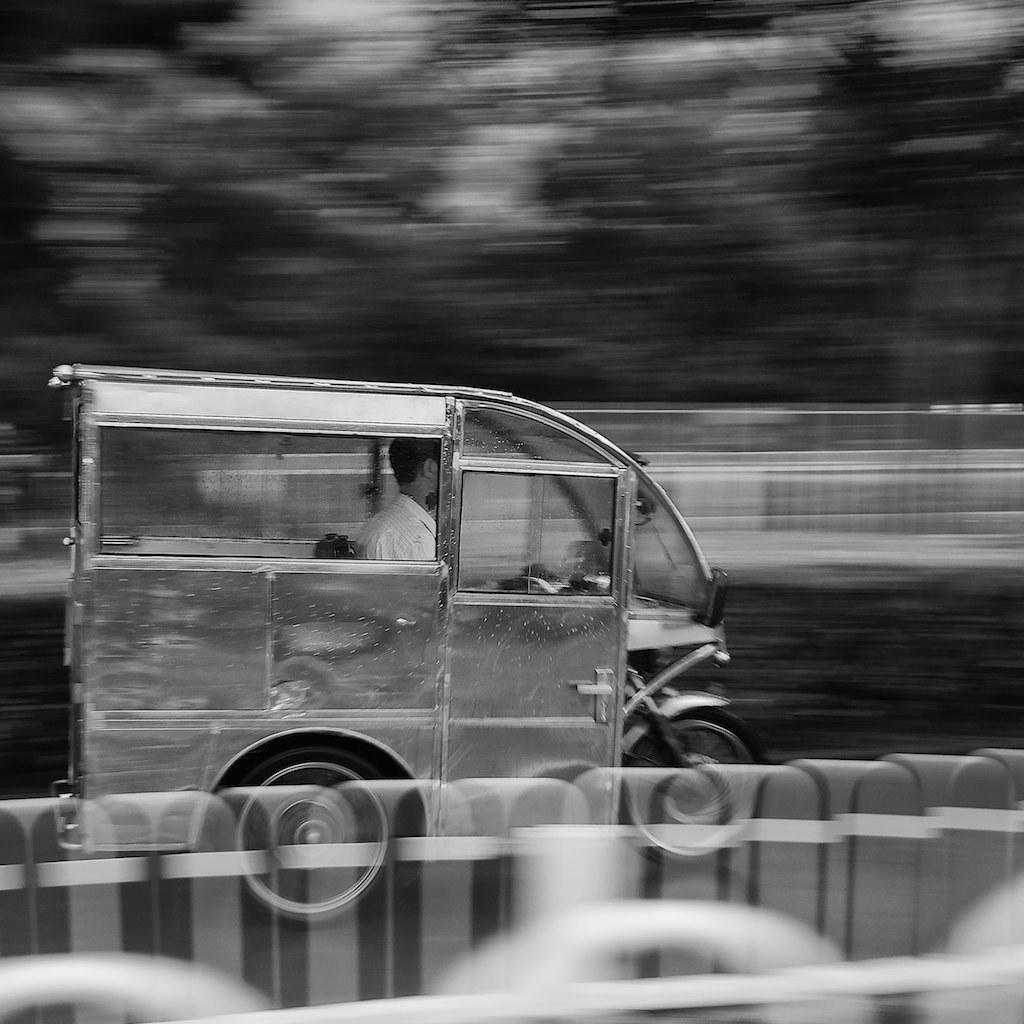Describe this image in one or two sentences. In this image I can see a man is riding the vehicle, it has glass windows. 